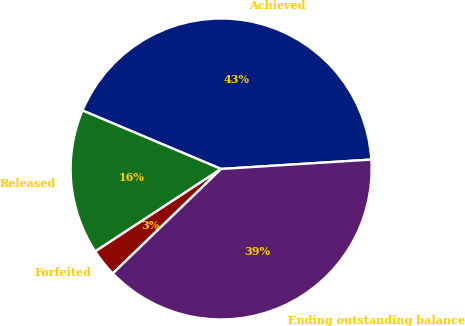<chart> <loc_0><loc_0><loc_500><loc_500><pie_chart><fcel>Achieved<fcel>Released<fcel>Forfeited<fcel>Ending outstanding balance<nl><fcel>42.65%<fcel>15.59%<fcel>2.98%<fcel>38.78%<nl></chart> 